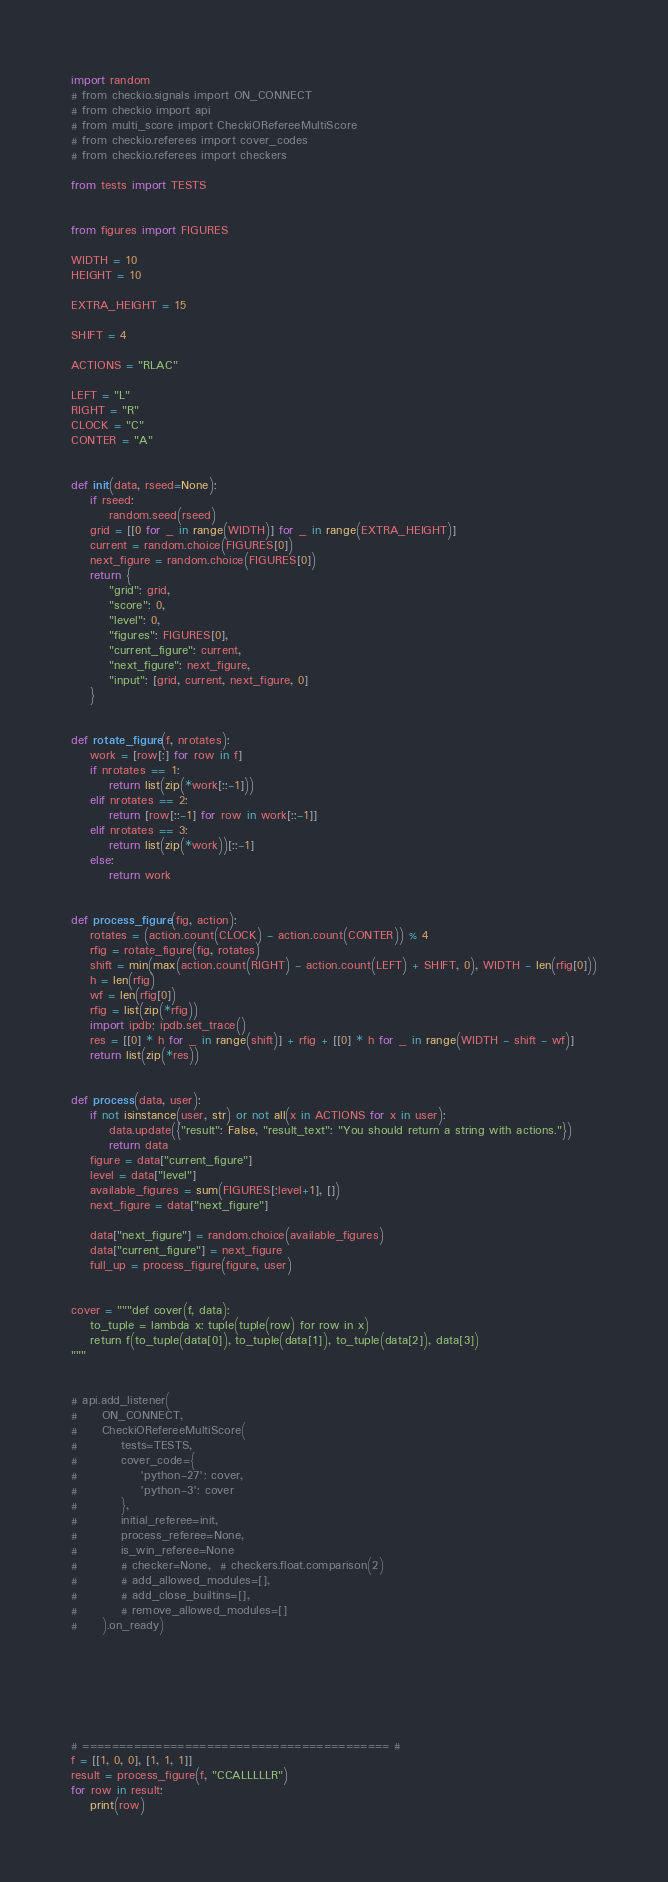<code> <loc_0><loc_0><loc_500><loc_500><_Python_>import random
# from checkio.signals import ON_CONNECT
# from checkio import api
# from multi_score import CheckiORefereeMultiScore
# from checkio.referees import cover_codes
# from checkio.referees import checkers

from tests import TESTS


from figures import FIGURES

WIDTH = 10
HEIGHT = 10

EXTRA_HEIGHT = 15

SHIFT = 4

ACTIONS = "RLAC"

LEFT = "L"
RIGHT = "R"
CLOCK = "C"
CONTER = "A"


def init(data, rseed=None):
    if rseed:
        random.seed(rseed)
    grid = [[0 for _ in range(WIDTH)] for _ in range(EXTRA_HEIGHT)]
    current = random.choice(FIGURES[0])
    next_figure = random.choice(FIGURES[0])
    return {
        "grid": grid,
        "score": 0,
        "level": 0,
        "figures": FIGURES[0],
        "current_figure": current,
        "next_figure": next_figure,
        "input": [grid, current, next_figure, 0]
    }


def rotate_figure(f, nrotates):
    work = [row[:] for row in f]
    if nrotates == 1:
        return list(zip(*work[::-1]))
    elif nrotates == 2:
        return [row[::-1] for row in work[::-1]]
    elif nrotates == 3:
        return list(zip(*work))[::-1]
    else:
        return work


def process_figure(fig, action):
    rotates = (action.count(CLOCK) - action.count(CONTER)) % 4
    rfig = rotate_figure(fig, rotates)
    shift = min(max(action.count(RIGHT) - action.count(LEFT) + SHIFT, 0), WIDTH - len(rfig[0]))
    h = len(rfig)
    wf = len(rfig[0])
    rfig = list(zip(*rfig))
    import ipdb; ipdb.set_trace()
    res = [[0] * h for _ in range(shift)] + rfig + [[0] * h for _ in range(WIDTH - shift - wf)]
    return list(zip(*res))


def process(data, user):
    if not isinstance(user, str) or not all(x in ACTIONS for x in user):
        data.update({"result": False, "result_text": "You should return a string with actions."})
        return data
    figure = data["current_figure"]
    level = data["level"]
    available_figures = sum(FIGURES[:level+1], [])
    next_figure = data["next_figure"]

    data["next_figure"] = random.choice(available_figures)
    data["current_figure"] = next_figure
    full_up = process_figure(figure, user)


cover = """def cover(f, data):
    to_tuple = lambda x: tuple(tuple(row) for row in x)
    return f(to_tuple(data[0]), to_tuple(data[1]), to_tuple(data[2]), data[3])
"""


# api.add_listener(
#     ON_CONNECT,
#     CheckiORefereeMultiScore(
#         tests=TESTS,
#         cover_code={
#             'python-27': cover,
#             'python-3': cover
#         },
#         initial_referee=init,
#         process_referee=None,
#         is_win_referee=None
#         # checker=None,  # checkers.float.comparison(2)
#         # add_allowed_modules=[],
#         # add_close_builtins=[],
#         # remove_allowed_modules=[]
#     ).on_ready)







# ========================================== #
f = [[1, 0, 0], [1, 1, 1]]
result = process_figure(f, "CCALLLLLR")
for row in result:
    print(row)
</code> 